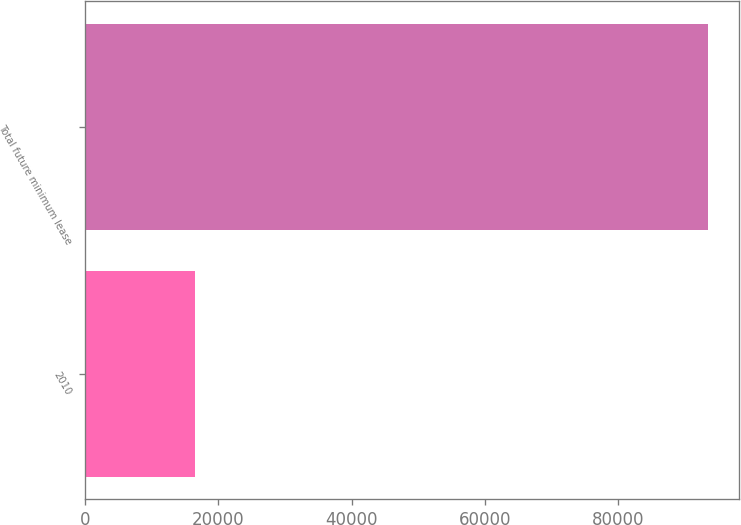Convert chart to OTSL. <chart><loc_0><loc_0><loc_500><loc_500><bar_chart><fcel>2010<fcel>Total future minimum lease<nl><fcel>16579<fcel>93504<nl></chart> 